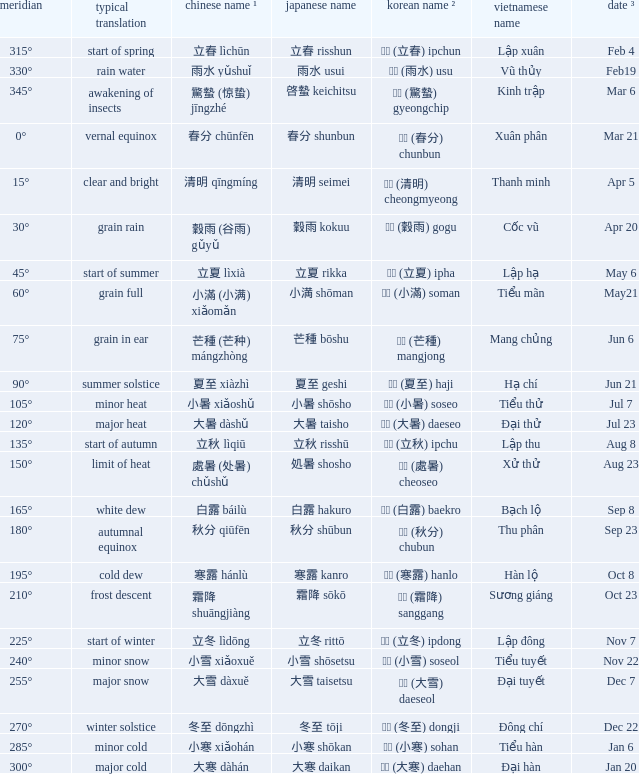WHICH Vietnamese name has a Chinese name ¹ of 芒種 (芒种) mángzhòng? Mang chủng. 